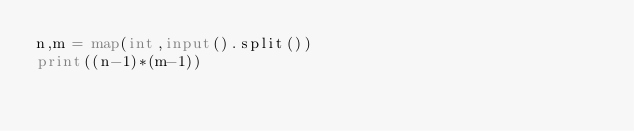<code> <loc_0><loc_0><loc_500><loc_500><_Python_>n,m = map(int,input().split())
print((n-1)*(m-1))</code> 